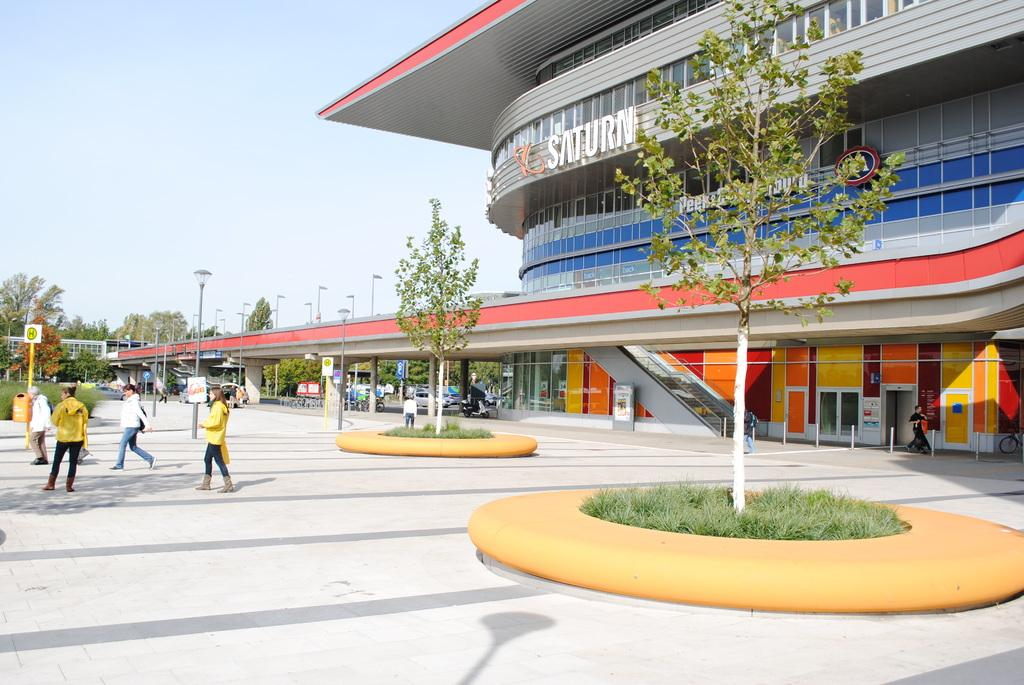<image>
Write a terse but informative summary of the picture. Several people wearing yellow are standing outside of a Saturn building 